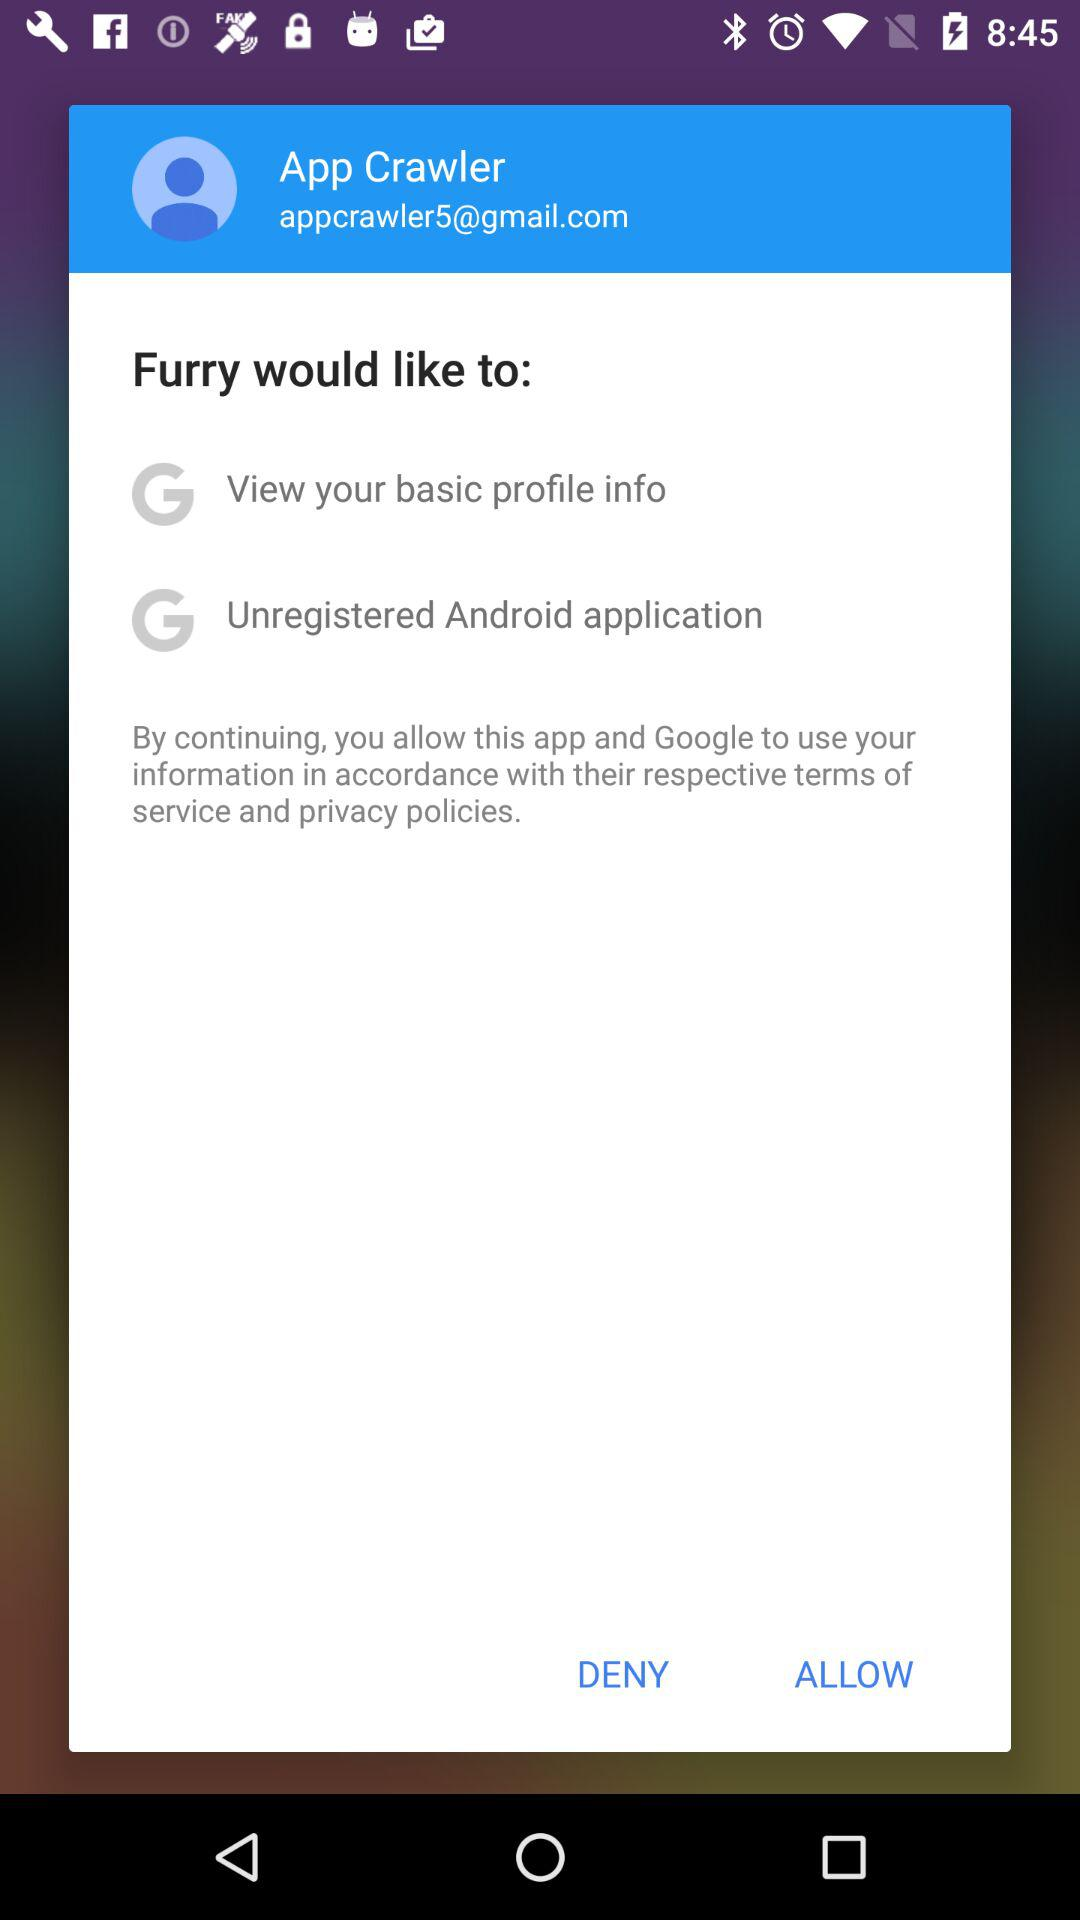What is the user name? The user name is App Crawler. 